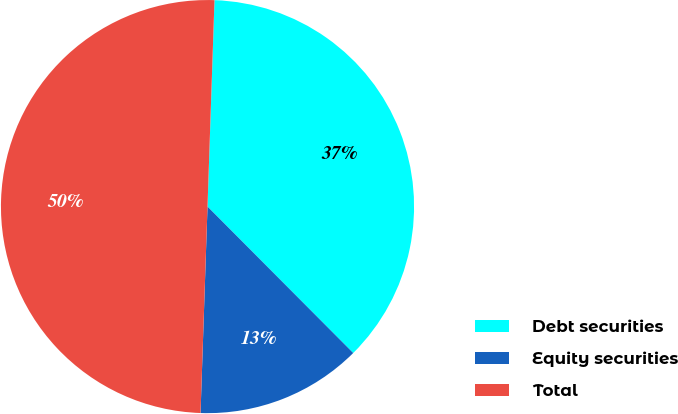Convert chart to OTSL. <chart><loc_0><loc_0><loc_500><loc_500><pie_chart><fcel>Debt securities<fcel>Equity securities<fcel>Total<nl><fcel>37.0%<fcel>13.0%<fcel>50.0%<nl></chart> 